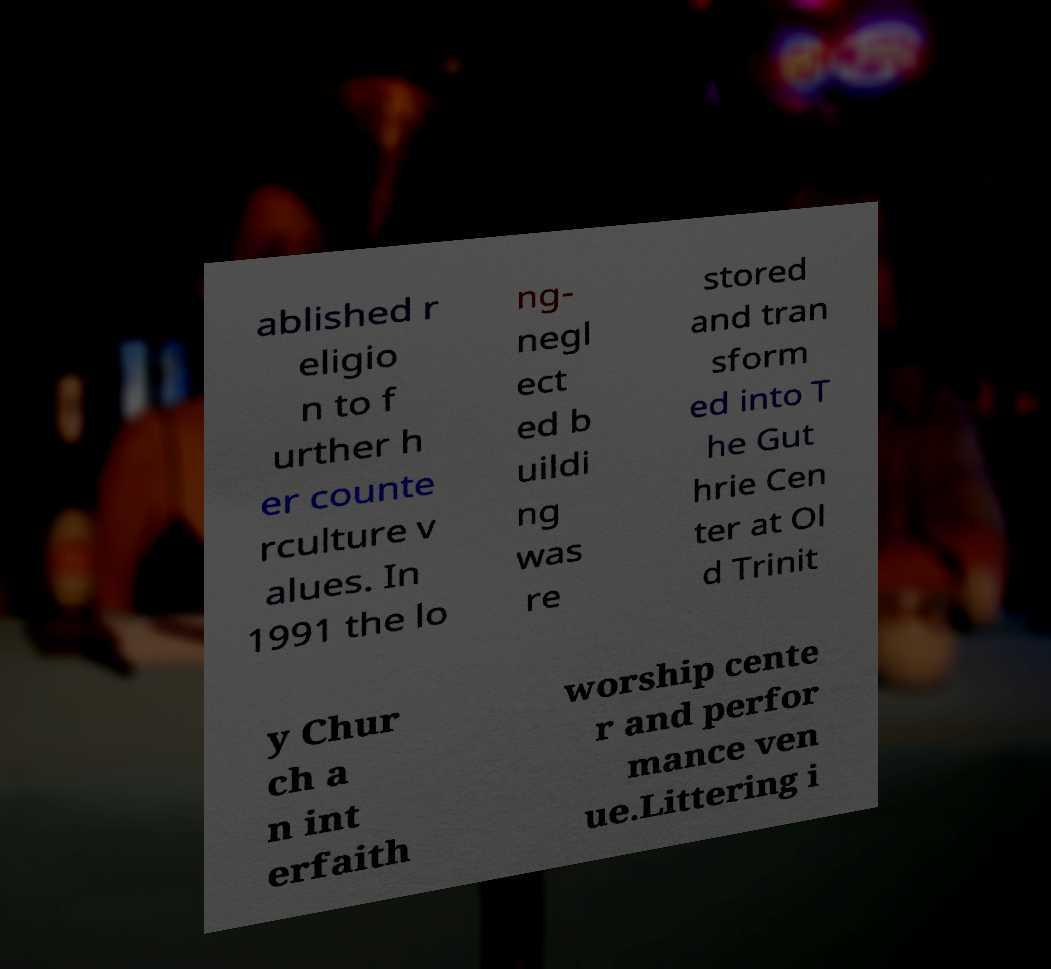For documentation purposes, I need the text within this image transcribed. Could you provide that? ablished r eligio n to f urther h er counte rculture v alues. In 1991 the lo ng- negl ect ed b uildi ng was re stored and tran sform ed into T he Gut hrie Cen ter at Ol d Trinit y Chur ch a n int erfaith worship cente r and perfor mance ven ue.Littering i 